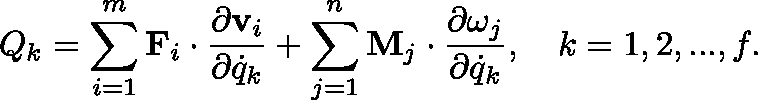Convert formula to latex. <formula><loc_0><loc_0><loc_500><loc_500>Q _ { k } = \sum _ { i = 1 } ^ { m } F _ { i } \cdot { \frac { \partial v _ { i } } { \partial { \dot { q } } _ { k } } } + \sum _ { j = 1 } ^ { n } M _ { j } \cdot { \frac { \partial \omega _ { j } } { \partial { \dot { q } } _ { k } } } , \quad k = 1 , 2 , \dots , f .</formula> 